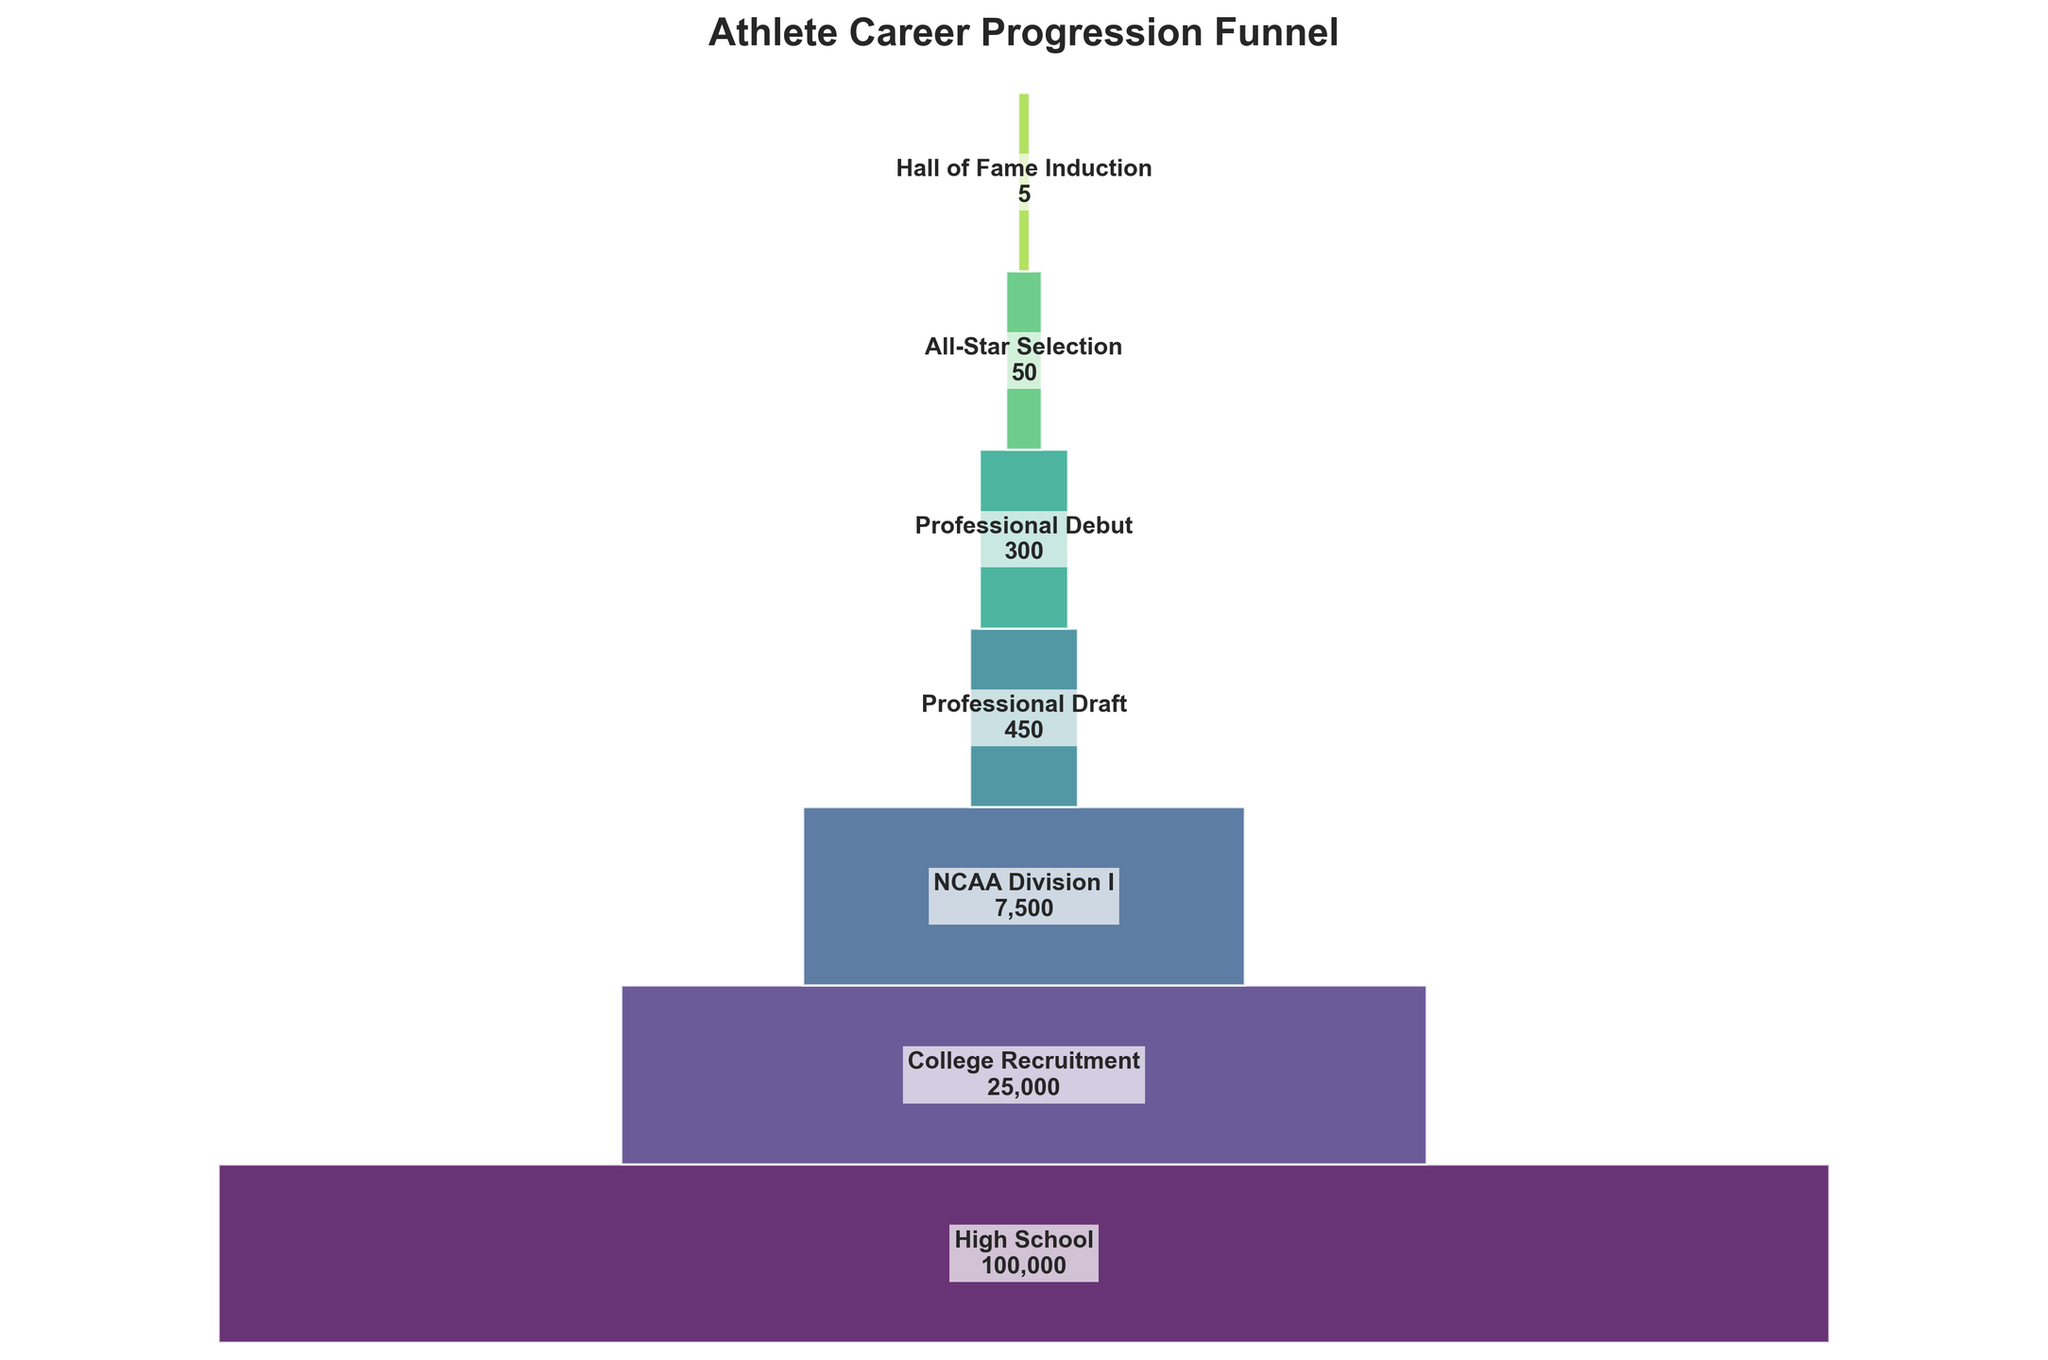what's the title of the figure? The figure's title is prominently displayed at the top. The title usually summarizes the main content or focus. Here, the title given is "Athlete Career Progression Funnel".
Answer: Athlete Career Progression Funnel how many stages are there in the funnel? By counting the distinct stages specified in the figure, starting from High School and ending at Hall of Fame Induction, you can determine the total number of stages.
Answer: 6 Which stage has the largest number of athletes? The figure mentions the number of athletes at each stage. By identifying the stage with the highest value, which here is High School with 100,000 athletes.
Answer: High School Which stage has the smallest representation in the funnel? By reviewing the values in the figure, the smallest number of athletes is found at the Hall of Fame Induction stage with 5 athletes.
Answer: Hall of Fame Induction How many stages see a reduction of at least 50% from the previous stage? For a 50% reduction, each subsequent stage should have half or less the number of athletes compared to the previous stage. By reviewing the data: 100,000 to 25,000 (75%), 25,000 to 7,500 (70%), 7,500 to 450 (94%), 450 to 300 (33%), 300 to 50 (83%), 50 to 5 (90%).
Answer: 4 What is the difference in the number of athletes between College Recruitment and NCAA Division I stages? Subtract the number of athletes in the NCAA Division I stage from those in the College Recruitment stage: 25,000 - 7,500 = 17,500.
Answer: 17,500 What is the percentage drop in athletes from Professional Debut to All-Star Selection? Calculate the difference: 300 - 50 = 250, then divide by the initial value (Professional Debut) and multiply by 100 (250 / 300) * 100 = approximately 83.33%.
Answer: 83.33% How many athletes transition from being drafted to making a professional debut? By reviewing the data, you see that the number of athletes in the Professional Draft stage is 450, and those making a Professional Debut are 300. Hence, 450 - 300 = 150 athletes make the transition.
Answer: 150 What percentage of High School athletes reach the Professional Draft stage? To find the percentage, divide the number of athletes reaching the Professional Draft stage by the number from High School and multiply by 100: (450 / 100,000) * 100 = 0.45%.
Answer: 0.45% How many steps in the funnel see fewer than 1,000 athletes? By examining the figure, we find stages with fewer than 1,000 athletes: Professional Debut (300), All-Star Selection (50), Hall of Fame Induction (5).
Answer: 3 